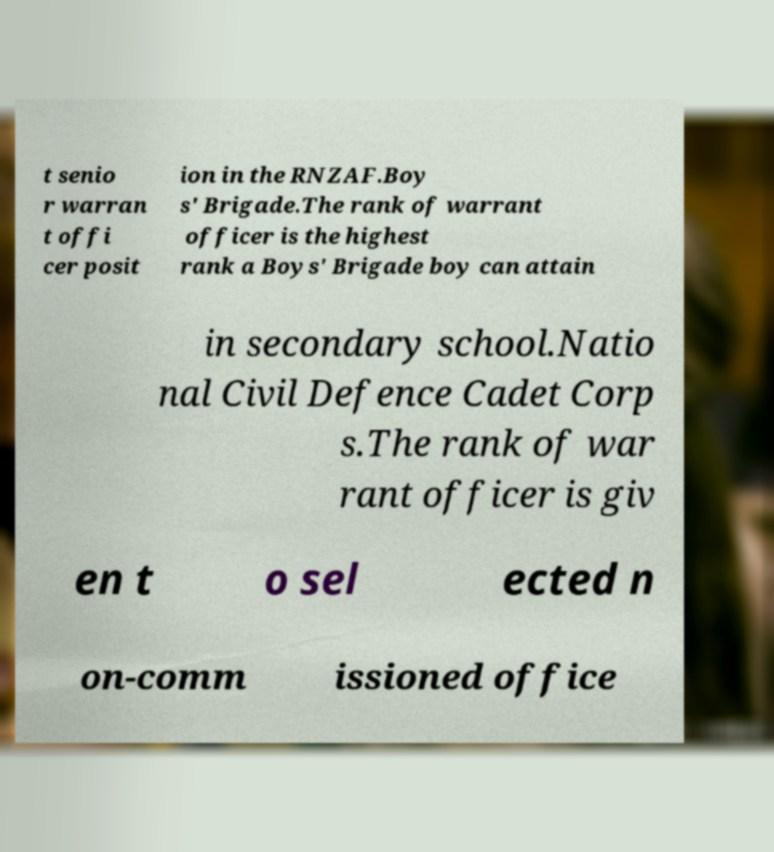What messages or text are displayed in this image? I need them in a readable, typed format. t senio r warran t offi cer posit ion in the RNZAF.Boy s' Brigade.The rank of warrant officer is the highest rank a Boys' Brigade boy can attain in secondary school.Natio nal Civil Defence Cadet Corp s.The rank of war rant officer is giv en t o sel ected n on-comm issioned office 